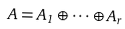Convert formula to latex. <formula><loc_0><loc_0><loc_500><loc_500>A = A _ { 1 } \oplus \cdots \oplus A _ { r }</formula> 